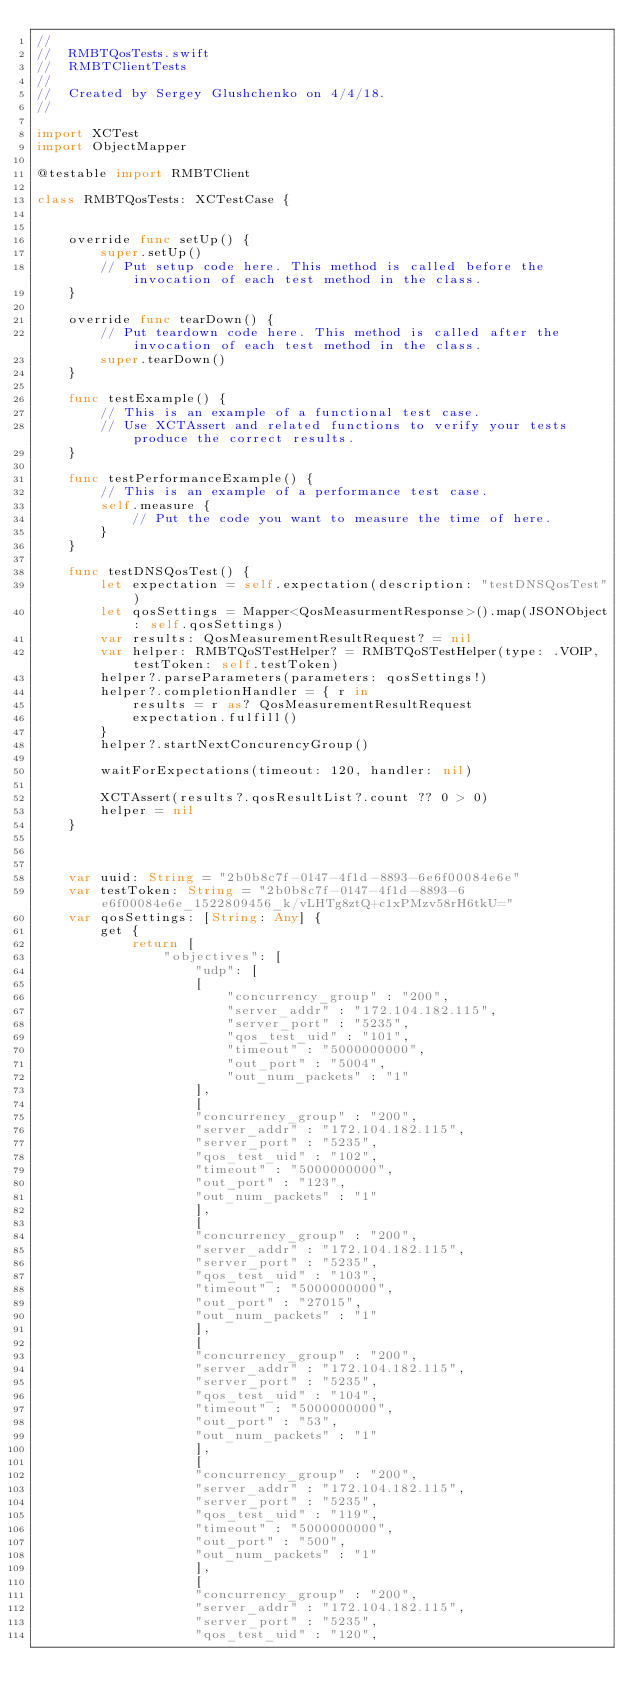<code> <loc_0><loc_0><loc_500><loc_500><_Swift_>//
//  RMBTQosTests.swift
//  RMBTClientTests
//
//  Created by Sergey Glushchenko on 4/4/18.
//

import XCTest
import ObjectMapper

@testable import RMBTClient

class RMBTQosTests: XCTestCase {
    
    
    override func setUp() {
        super.setUp()
        // Put setup code here. This method is called before the invocation of each test method in the class.
    }
    
    override func tearDown() {
        // Put teardown code here. This method is called after the invocation of each test method in the class.
        super.tearDown()
    }
    
    func testExample() {
        // This is an example of a functional test case.
        // Use XCTAssert and related functions to verify your tests produce the correct results.
    }
    
    func testPerformanceExample() {
        // This is an example of a performance test case.
        self.measure {
            // Put the code you want to measure the time of here.
        }
    }
    
    func testDNSQosTest() {
        let expectation = self.expectation(description: "testDNSQosTest")
        let qosSettings = Mapper<QosMeasurmentResponse>().map(JSONObject: self.qosSettings)
        var results: QosMeasurementResultRequest? = nil
        var helper: RMBTQoSTestHelper? = RMBTQoSTestHelper(type: .VOIP, testToken: self.testToken)
        helper?.parseParameters(parameters: qosSettings!)
        helper?.completionHandler = { r in
            results = r as? QosMeasurementResultRequest
            expectation.fulfill()
        }
        helper?.startNextConcurencyGroup()
        
        waitForExpectations(timeout: 120, handler: nil)
        
        XCTAssert(results?.qosResultList?.count ?? 0 > 0)
        helper = nil
    }
    
    
    
    var uuid: String = "2b0b8c7f-0147-4f1d-8893-6e6f00084e6e"
    var testToken: String = "2b0b8c7f-0147-4f1d-8893-6e6f00084e6e_1522809456_k/vLHTg8ztQ+c1xPMzv58rH6tkU="
    var qosSettings: [String: Any] {
        get {
            return [
                "objectives": [
                    "udp": [
                    [
                        "concurrency_group" : "200",
                        "server_addr" : "172.104.182.115",
                        "server_port" : "5235",
                        "qos_test_uid" : "101",
                        "timeout" : "5000000000",
                        "out_port" : "5004",
                        "out_num_packets" : "1"
                    ],
                    [
                    "concurrency_group" : "200",
                    "server_addr" : "172.104.182.115",
                    "server_port" : "5235",
                    "qos_test_uid" : "102",
                    "timeout" : "5000000000",
                    "out_port" : "123",
                    "out_num_packets" : "1"
                    ],
                    [
                    "concurrency_group" : "200",
                    "server_addr" : "172.104.182.115",
                    "server_port" : "5235",
                    "qos_test_uid" : "103",
                    "timeout" : "5000000000",
                    "out_port" : "27015",
                    "out_num_packets" : "1"
                    ],
                    [
                    "concurrency_group" : "200",
                    "server_addr" : "172.104.182.115",
                    "server_port" : "5235",
                    "qos_test_uid" : "104",
                    "timeout" : "5000000000",
                    "out_port" : "53",
                    "out_num_packets" : "1"
                    ],
                    [
                    "concurrency_group" : "200",
                    "server_addr" : "172.104.182.115",
                    "server_port" : "5235",
                    "qos_test_uid" : "119",
                    "timeout" : "5000000000",
                    "out_port" : "500",
                    "out_num_packets" : "1"
                    ],
                    [
                    "concurrency_group" : "200",
                    "server_addr" : "172.104.182.115",
                    "server_port" : "5235",
                    "qos_test_uid" : "120",</code> 